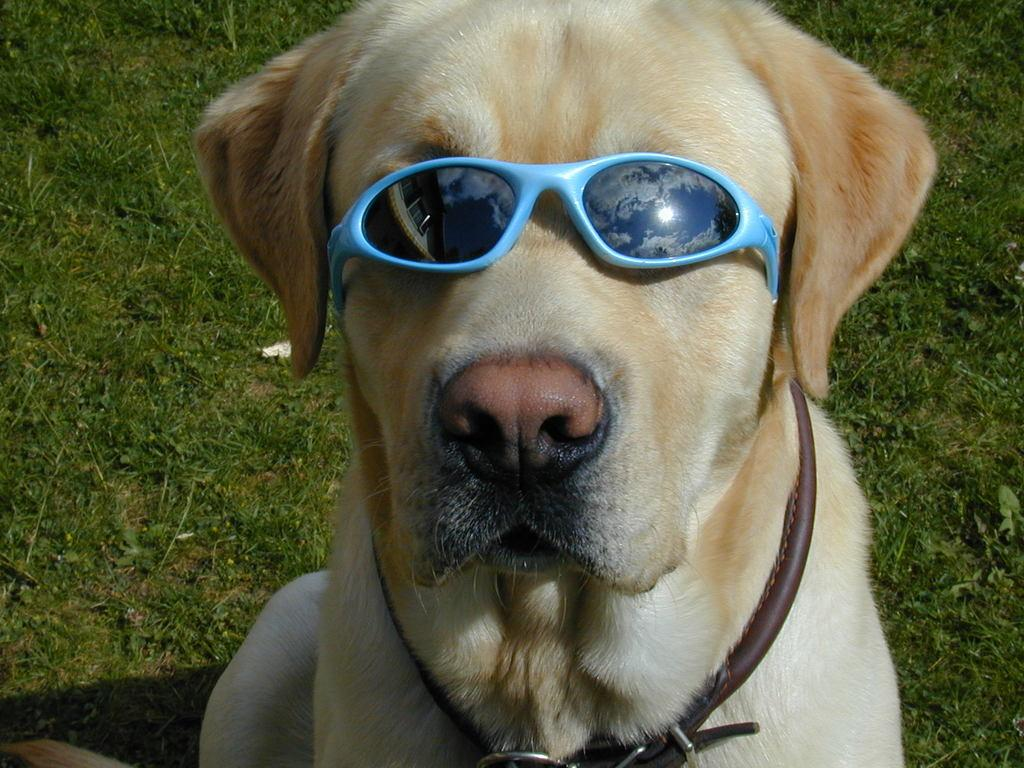What animal is present in the image? There is a dog in the image. Where is the dog situated in the image? The dog is sitting on a greenery ground. What accessory is the dog wearing in the image? The dog is wearing goggles. What type of ghost can be seen interacting with the dog in the image? There is no ghost present in the image; it features a dog sitting on a greenery ground and wearing goggles. What type of brass object is visible in the image? There is no brass object present in the image. 